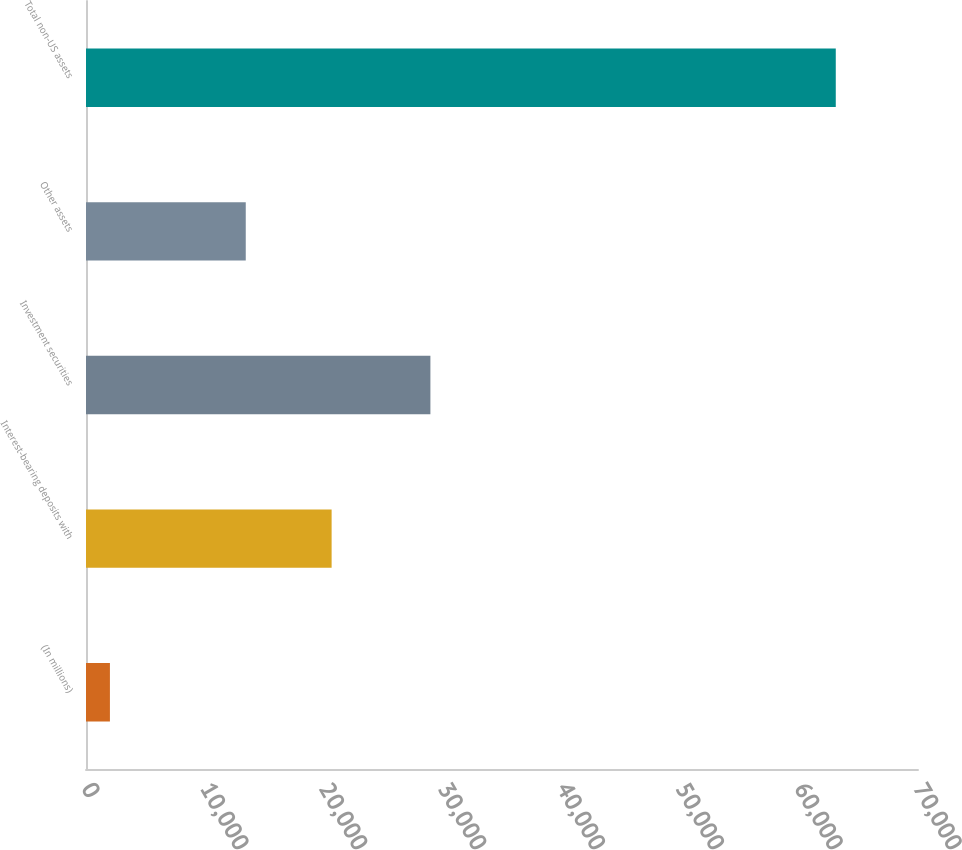<chart> <loc_0><loc_0><loc_500><loc_500><bar_chart><fcel>(In millions)<fcel>Interest-bearing deposits with<fcel>Investment securities<fcel>Other assets<fcel>Total non-US assets<nl><fcel>2012<fcel>20665<fcel>28976<fcel>13441<fcel>63082<nl></chart> 